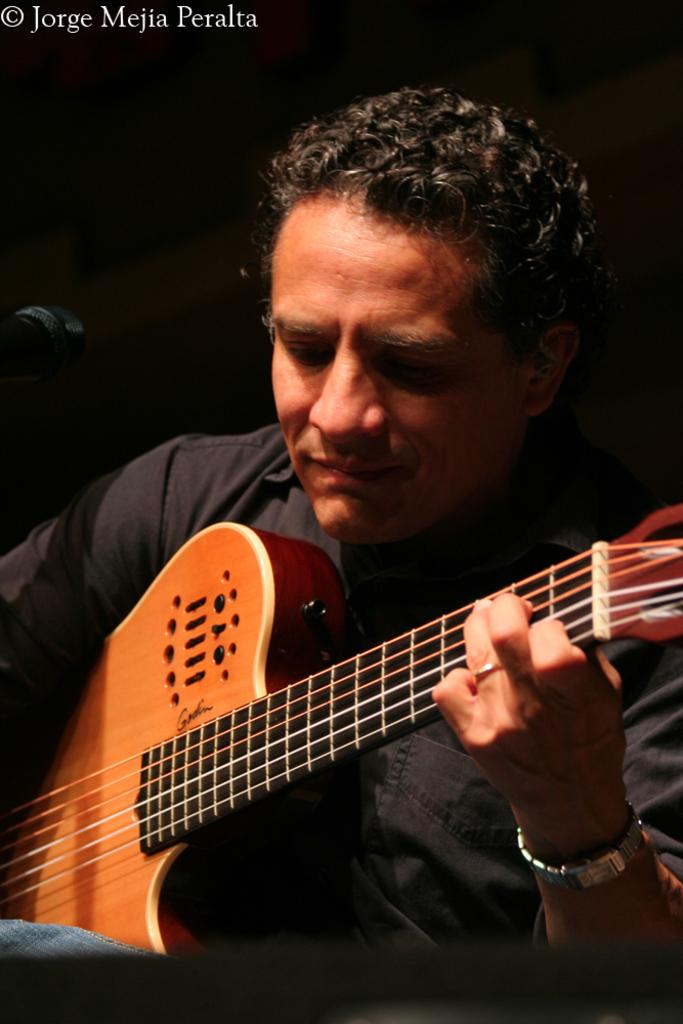What is the main subject of the image? The main subject of the image is a man. What is the man doing in the image? The man is playing a guitar in the image. What type of kettle is the man using to play the guitar in the image? There is no kettle present in the image, and the man is not using any kettle to play the guitar. 